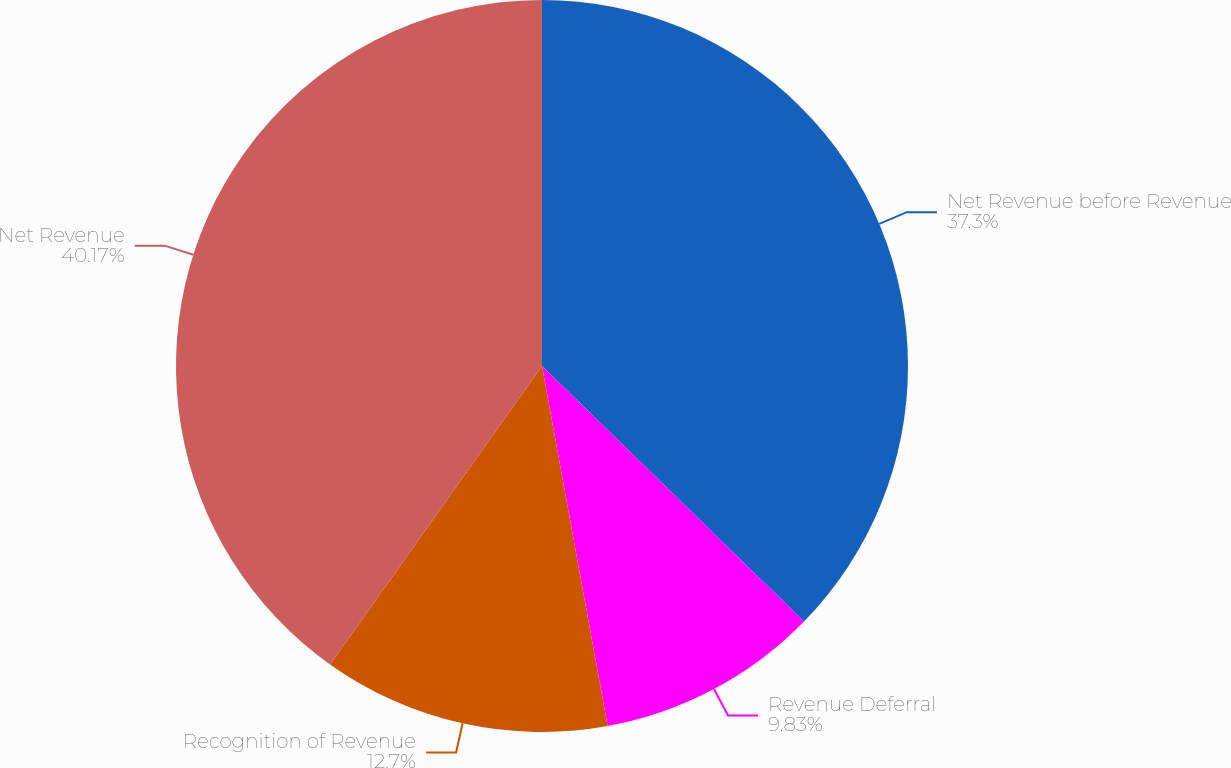<chart> <loc_0><loc_0><loc_500><loc_500><pie_chart><fcel>Net Revenue before Revenue<fcel>Revenue Deferral<fcel>Recognition of Revenue<fcel>Net Revenue<nl><fcel>37.3%<fcel>9.83%<fcel>12.7%<fcel>40.17%<nl></chart> 